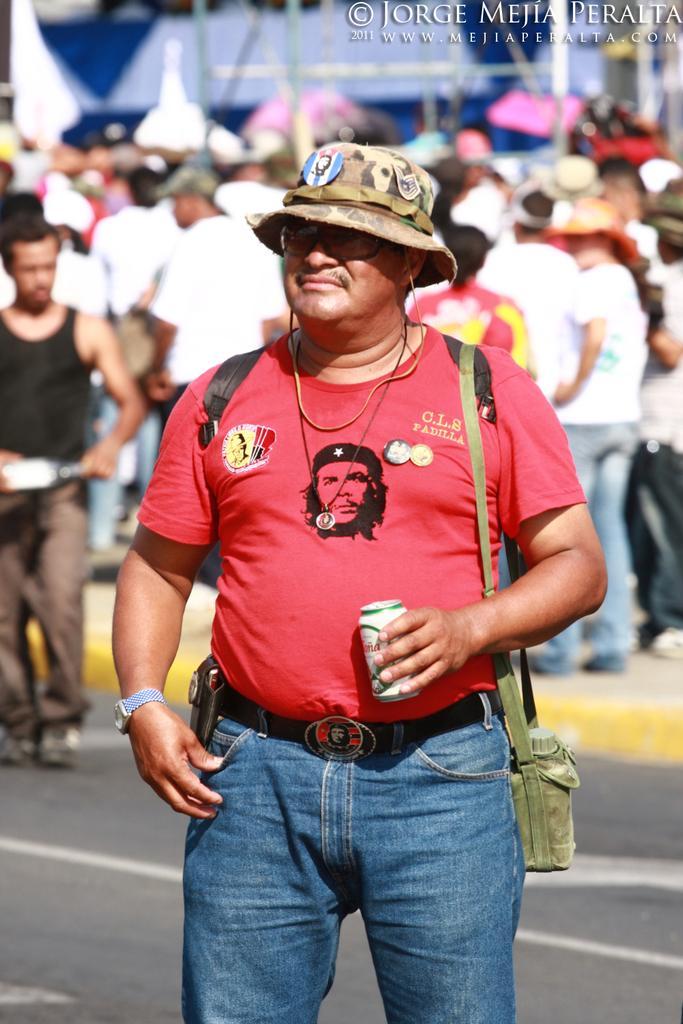Describe this image in one or two sentences. In the picture we can see a person wearing red color T-shirt, blue color jeans, carrying backpack, also wearing hat standing on road and in the background of the picture there are some persons standing. 